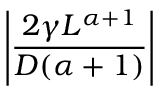Convert formula to latex. <formula><loc_0><loc_0><loc_500><loc_500>\left | \frac { 2 \gamma L ^ { \alpha + 1 } } { D ( \alpha + 1 ) } \right |</formula> 